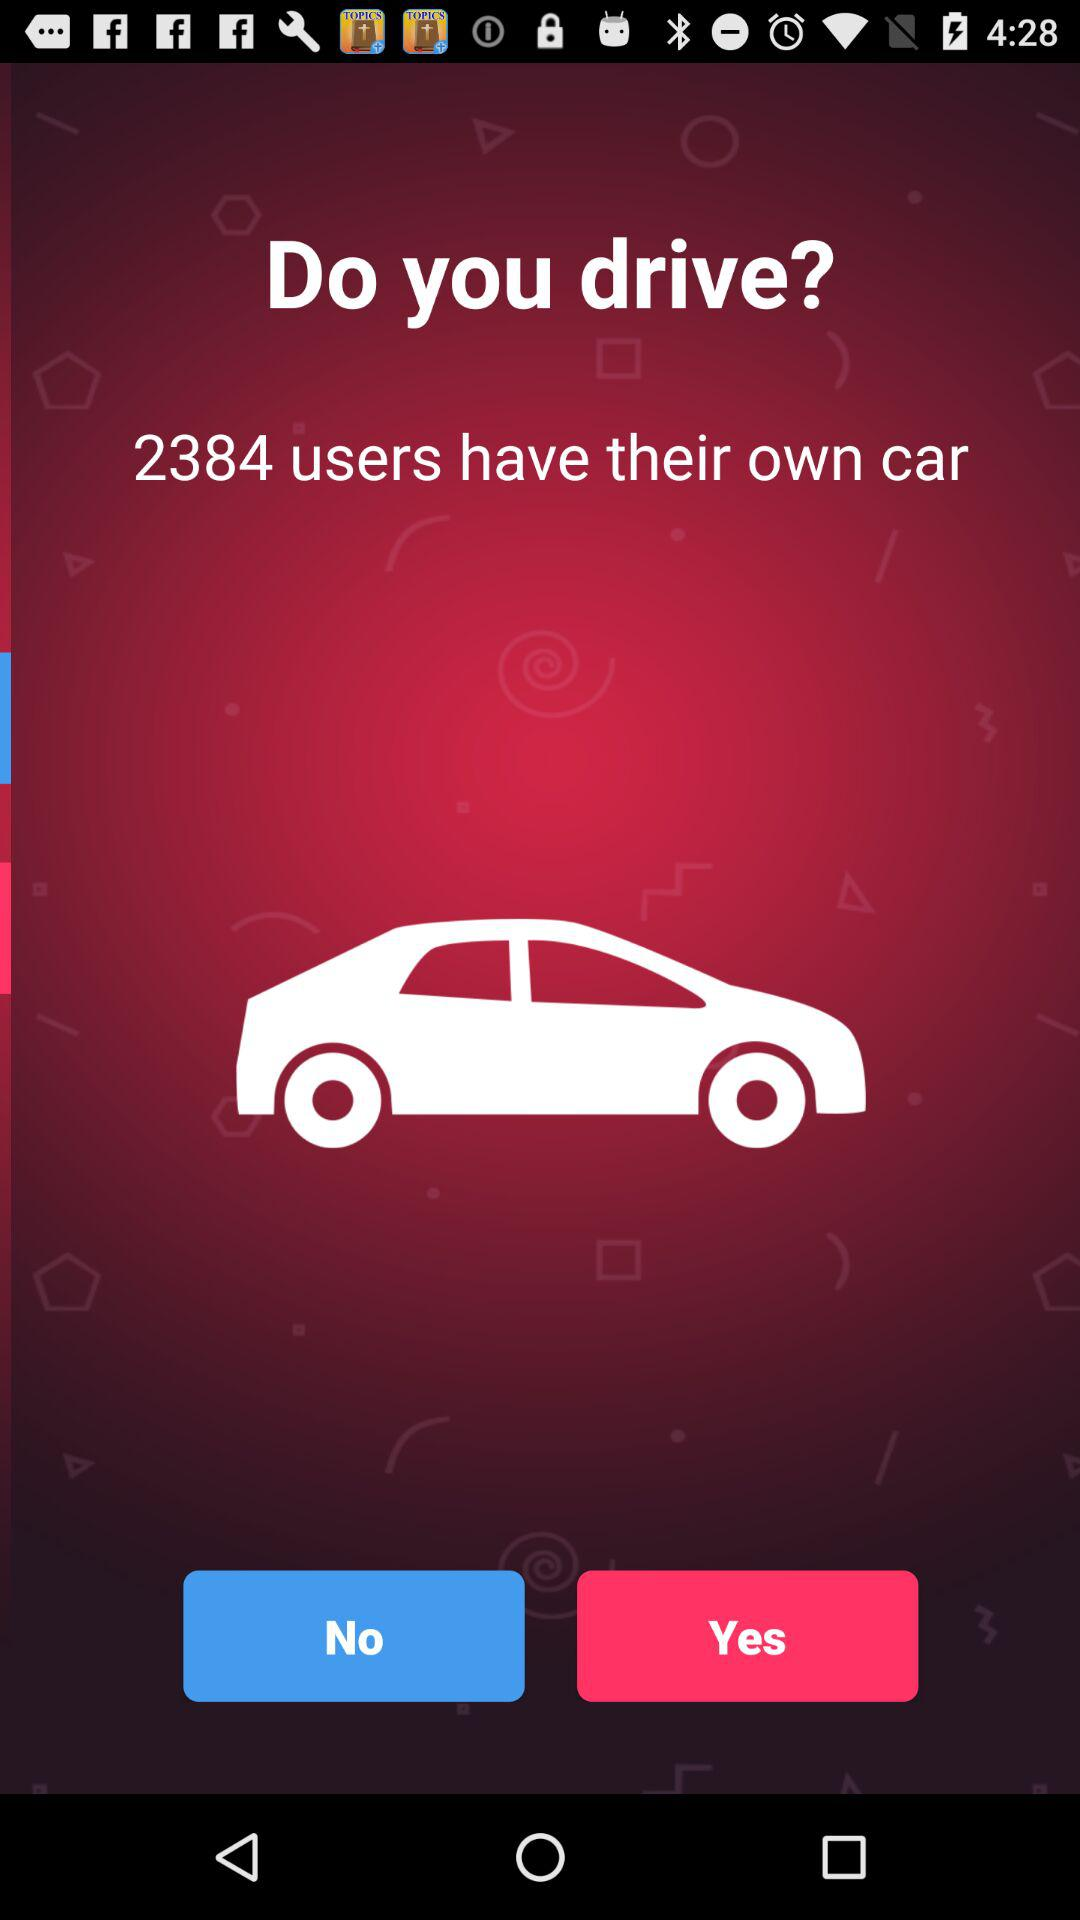How many users have their own car? There are 2384 users who have their own cars. 